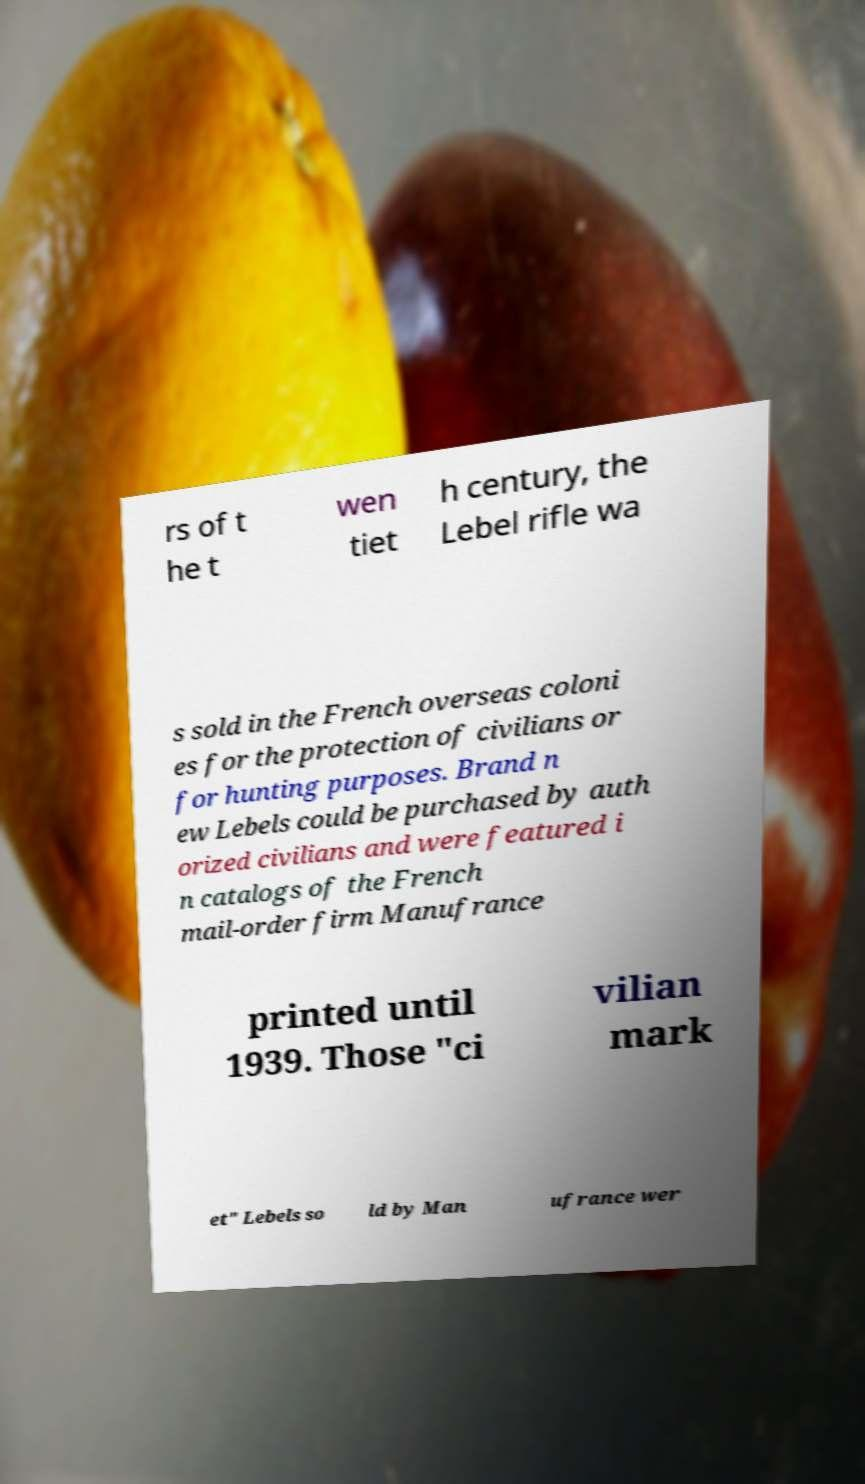What messages or text are displayed in this image? I need them in a readable, typed format. rs of t he t wen tiet h century, the Lebel rifle wa s sold in the French overseas coloni es for the protection of civilians or for hunting purposes. Brand n ew Lebels could be purchased by auth orized civilians and were featured i n catalogs of the French mail-order firm Manufrance printed until 1939. Those "ci vilian mark et" Lebels so ld by Man ufrance wer 